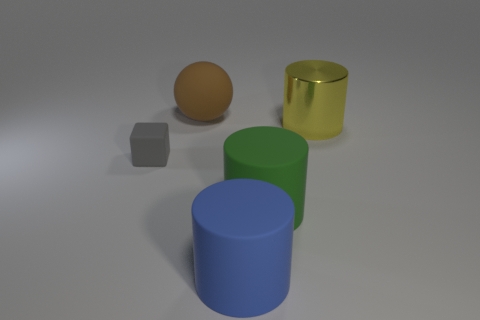Is there any other thing that has the same material as the yellow thing?
Provide a succinct answer. No. Does the big object in front of the big green matte object have the same shape as the large matte object that is right of the large blue cylinder?
Offer a terse response. Yes. How many cubes are large green objects or large brown objects?
Ensure brevity in your answer.  0. There is a thing on the left side of the large rubber thing that is behind the matte thing that is left of the sphere; what is it made of?
Ensure brevity in your answer.  Rubber. What number of other things are the same size as the brown sphere?
Provide a short and direct response. 3. Is the number of matte cylinders left of the big green cylinder greater than the number of tiny brown shiny balls?
Your answer should be very brief. Yes. Are there any blocks that have the same color as the big matte sphere?
Your answer should be very brief. No. There is another metal cylinder that is the same size as the green cylinder; what is its color?
Offer a very short reply. Yellow. What number of yellow things are right of the large matte object that is behind the large yellow metal object?
Keep it short and to the point. 1. How many things are things that are to the right of the small gray matte cube or tiny purple rubber things?
Provide a short and direct response. 4. 